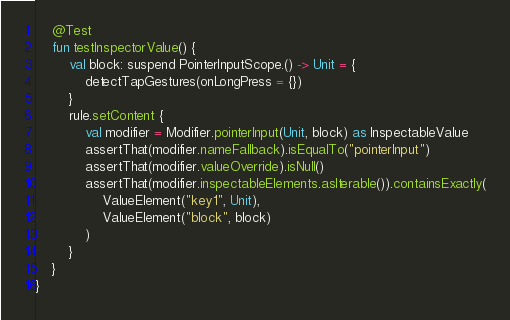<code> <loc_0><loc_0><loc_500><loc_500><_Kotlin_>
    @Test
    fun testInspectorValue() {
        val block: suspend PointerInputScope.() -> Unit = {
            detectTapGestures(onLongPress = {})
        }
        rule.setContent {
            val modifier = Modifier.pointerInput(Unit, block) as InspectableValue
            assertThat(modifier.nameFallback).isEqualTo("pointerInput")
            assertThat(modifier.valueOverride).isNull()
            assertThat(modifier.inspectableElements.asIterable()).containsExactly(
                ValueElement("key1", Unit),
                ValueElement("block", block)
            )
        }
    }
}
</code> 